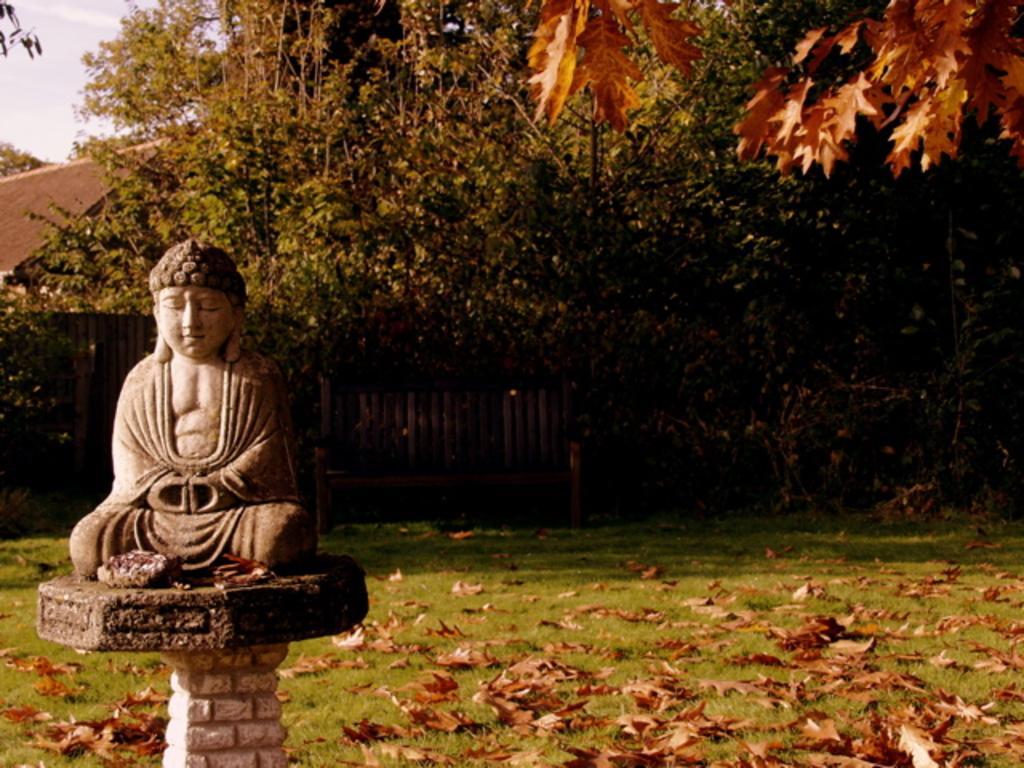Describe this image in one or two sentences. In this picture I can see the Buddha statue which is placed on the wall. In the background I can see many trees and shed. In the top left corner I can see the sky and clouds. At the bottom I can see many leaves and grass. 